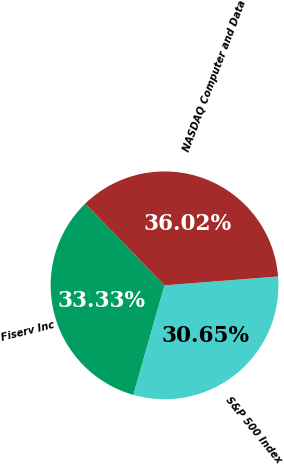<chart> <loc_0><loc_0><loc_500><loc_500><pie_chart><fcel>Fiserv Inc<fcel>S&P 500 Index<fcel>NASDAQ Computer and Data<nl><fcel>33.33%<fcel>30.65%<fcel>36.02%<nl></chart> 